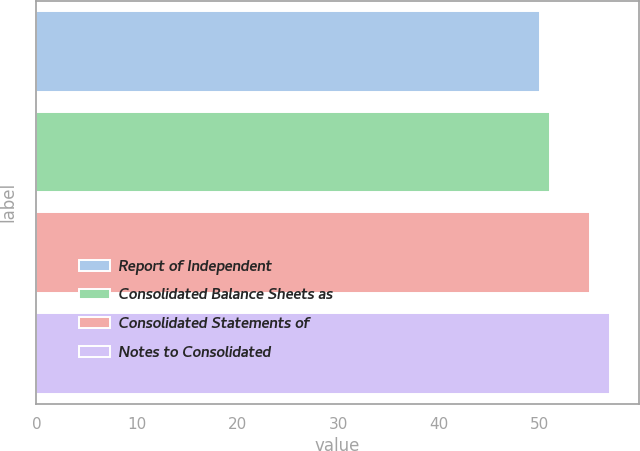Convert chart. <chart><loc_0><loc_0><loc_500><loc_500><bar_chart><fcel>Report of Independent<fcel>Consolidated Balance Sheets as<fcel>Consolidated Statements of<fcel>Notes to Consolidated<nl><fcel>50<fcel>51<fcel>55<fcel>57<nl></chart> 